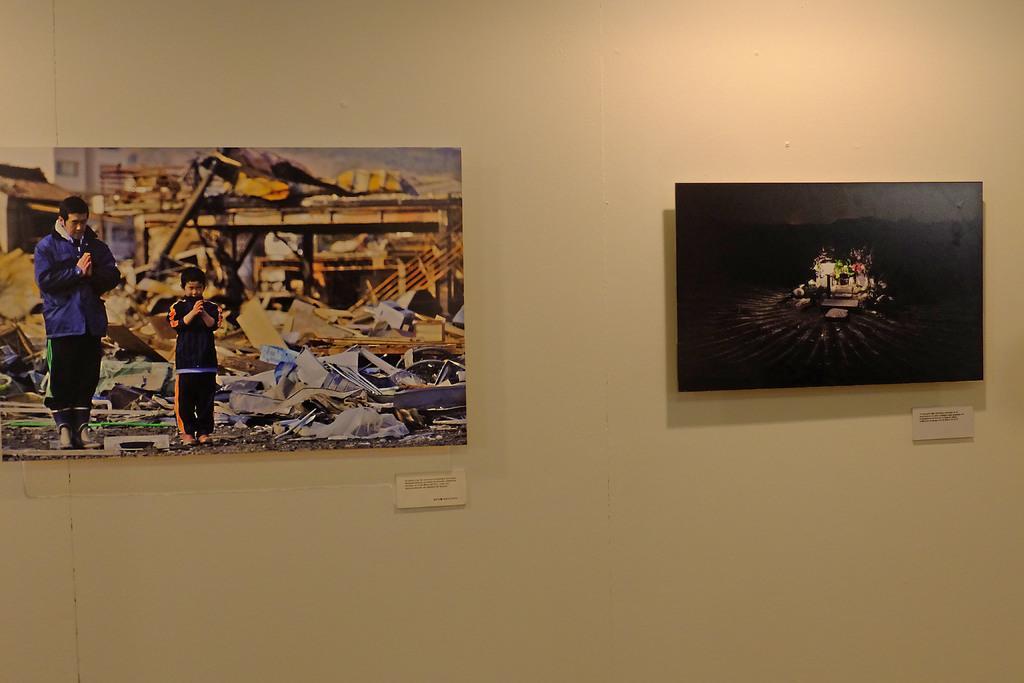Can you describe this image briefly? In the image we can see the photos stick to the wall. In the left side photo we can see a man and a child wearing clothes, shoes and it looks like they are praying. 